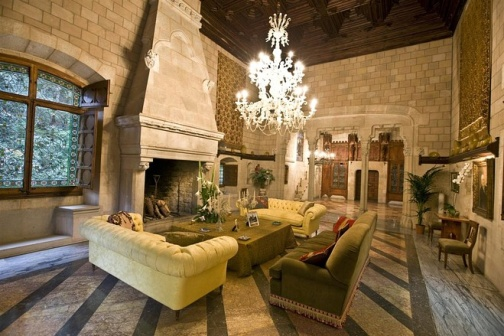What might be the purpose of such a room in a house? A room like this serves multiple purposes. It's primarily a formal living area designed for entertaining guests, conducting social gatherings, or enjoying quiet relaxation. Its spacious layout, with comfortable seating and ambient lighting, provides an ideal setting for conversation and leisure. Additionally, the fireplace adds an element of warmth, creating a cozy atmosphere during colder months. It's a space that balances elegance with comfort, making it suitable for various occasions. Given its luxurious features, could this room have other uses besides entertainment? Certainly, beyond entertainment, this luxurious living room might also serve as a stately backdrop for important family events or ceremonies. It could be used for photo sessions during special occasions like weddings or anniversaries. Additionally, one can imagine it being a space for reflection or enjoying a quiet evening by the fire, perhaps while reading a book or listening to music — the opulent elements not only serving aesthetic purposes but also enhancing the overall experience of comfort and respite. 